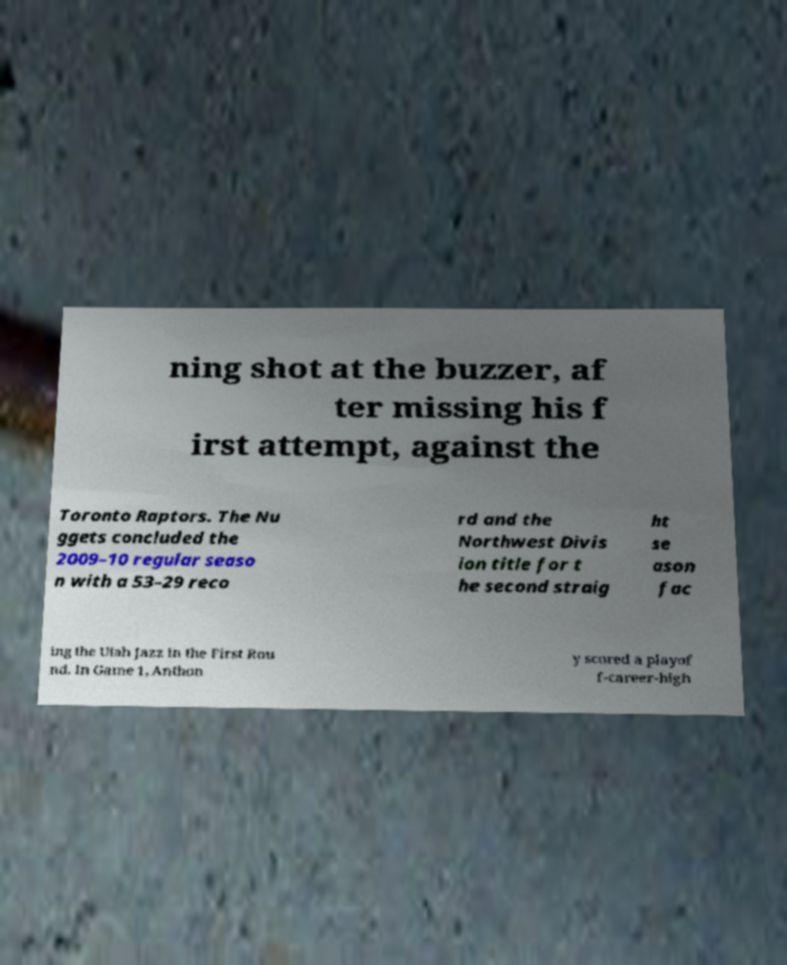Please read and relay the text visible in this image. What does it say? ning shot at the buzzer, af ter missing his f irst attempt, against the Toronto Raptors. The Nu ggets concluded the 2009–10 regular seaso n with a 53–29 reco rd and the Northwest Divis ion title for t he second straig ht se ason fac ing the Utah Jazz in the First Rou nd. In Game 1, Anthon y scored a playof f-career-high 